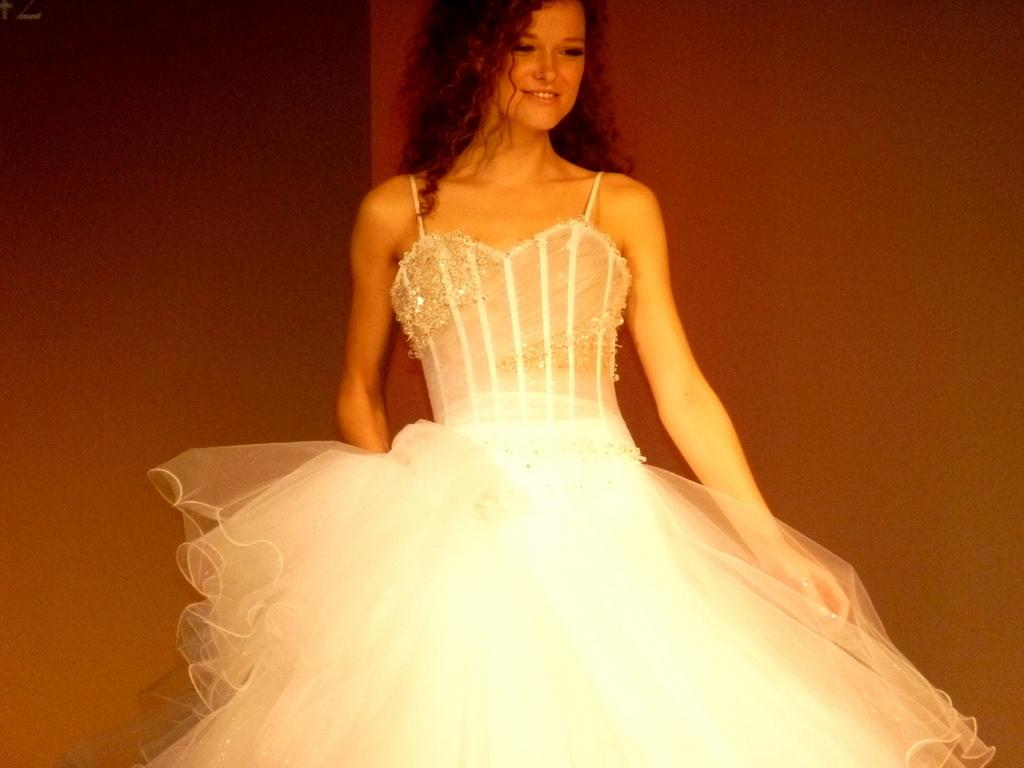What is the main subject of the image? There is a woman standing in the image. Can you describe the background of the image? There is a wall in the background of the image. What type of air can be seen coming out of the woman's mouth in the image? There is no air visible coming out of the woman's mouth in the image. 